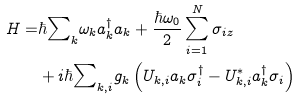Convert formula to latex. <formula><loc_0><loc_0><loc_500><loc_500>H = & \hbar { \sum } _ { k } \omega _ { k } a _ { k } ^ { \dagger } a _ { k } + \frac { \hbar { \omega } _ { 0 } } { 2 } \sum _ { i = 1 } ^ { N } \sigma _ { i z } \\ & + i \hbar { \sum } _ { { k } , i } g _ { k } \left ( U _ { { k } , i } a _ { k } \sigma _ { i } ^ { \dagger } - U _ { { k } , i } ^ { \ast } a _ { k } ^ { \dagger } \sigma _ { i } \right )</formula> 